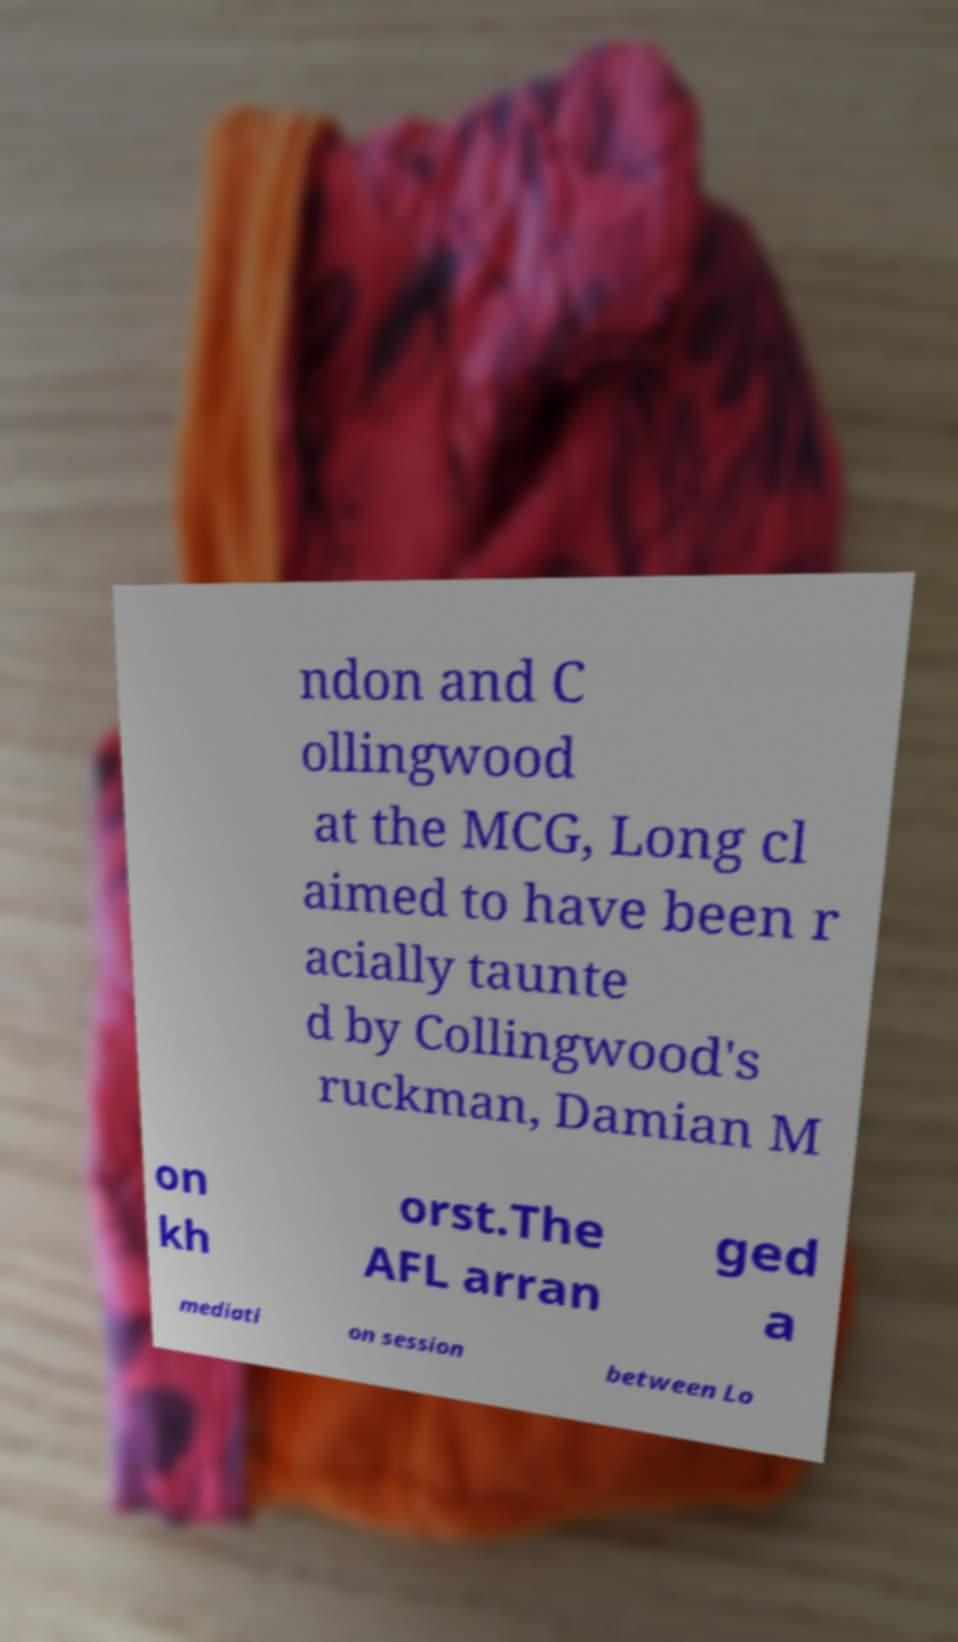Could you extract and type out the text from this image? ndon and C ollingwood at the MCG, Long cl aimed to have been r acially taunte d by Collingwood's ruckman, Damian M on kh orst.The AFL arran ged a mediati on session between Lo 